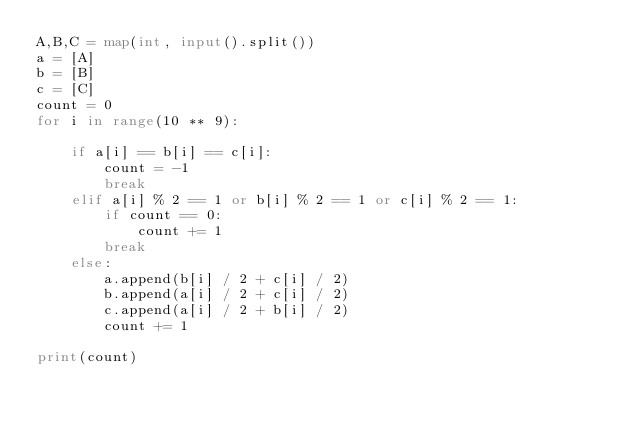Convert code to text. <code><loc_0><loc_0><loc_500><loc_500><_Python_>A,B,C = map(int, input().split())
a = [A]
b = [B]
c = [C]
count = 0
for i in range(10 ** 9):
 
    if a[i] == b[i] == c[i]:
        count = -1
        break
    elif a[i] % 2 == 1 or b[i] % 2 == 1 or c[i] % 2 == 1:
        if count == 0:
            count += 1
        break
    else:
        a.append(b[i] / 2 + c[i] / 2)
        b.append(a[i] / 2 + c[i] / 2)
        c.append(a[i] / 2 + b[i] / 2)
        count += 1

print(count)
</code> 